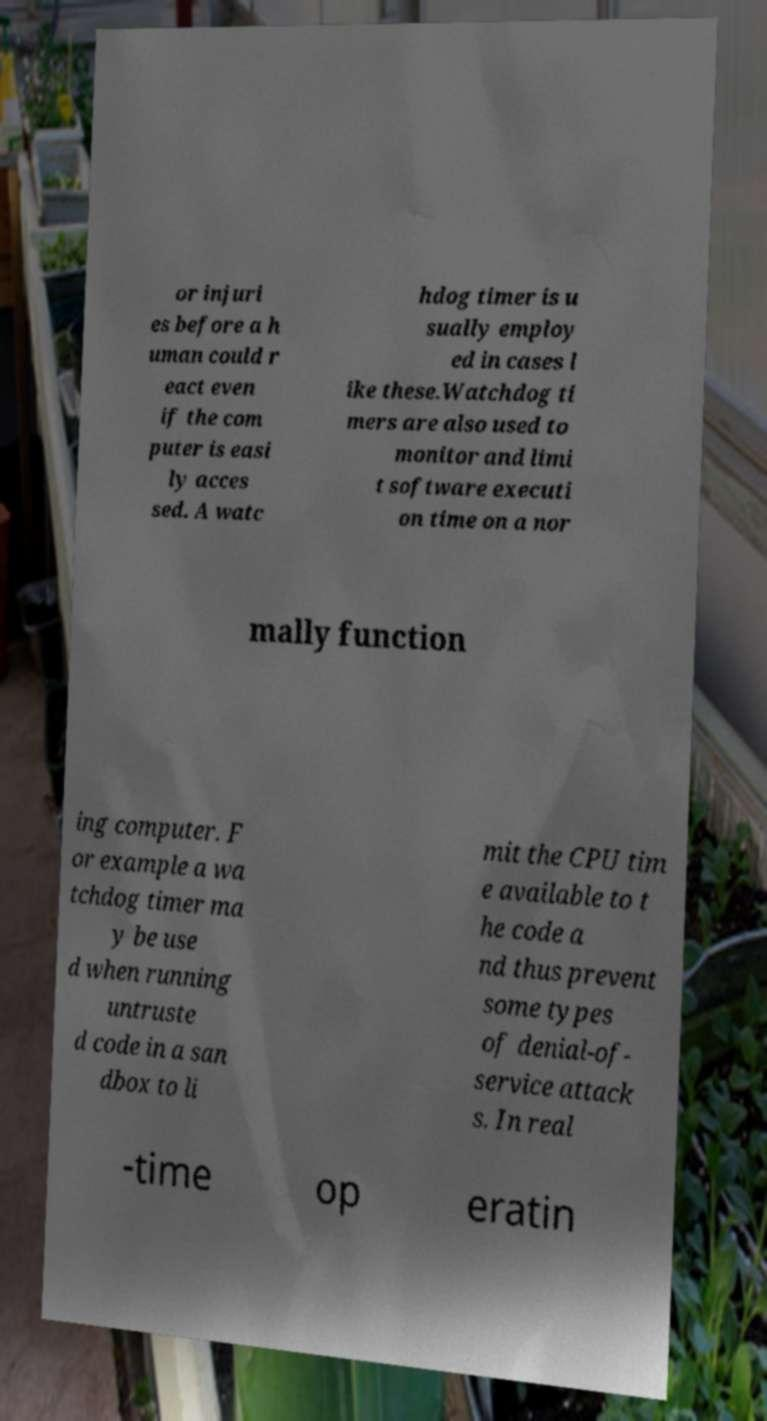Can you read and provide the text displayed in the image?This photo seems to have some interesting text. Can you extract and type it out for me? or injuri es before a h uman could r eact even if the com puter is easi ly acces sed. A watc hdog timer is u sually employ ed in cases l ike these.Watchdog ti mers are also used to monitor and limi t software executi on time on a nor mally function ing computer. F or example a wa tchdog timer ma y be use d when running untruste d code in a san dbox to li mit the CPU tim e available to t he code a nd thus prevent some types of denial-of- service attack s. In real -time op eratin 